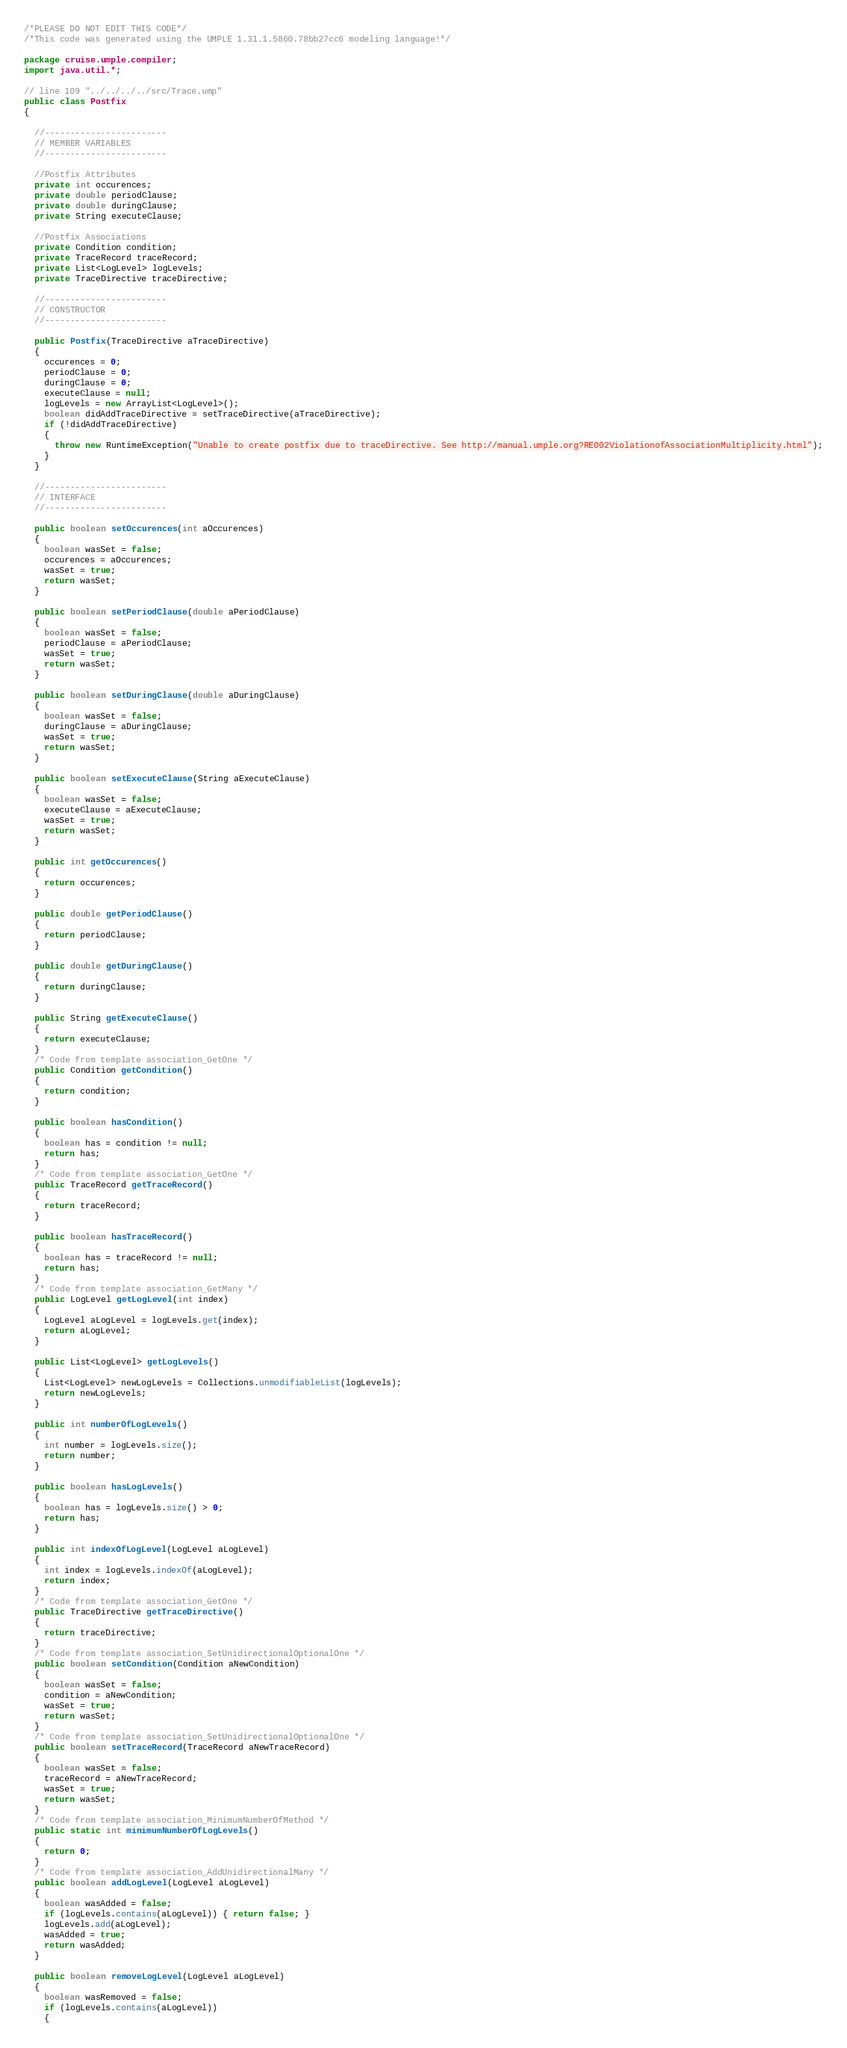Convert code to text. <code><loc_0><loc_0><loc_500><loc_500><_Java_>/*PLEASE DO NOT EDIT THIS CODE*/
/*This code was generated using the UMPLE 1.31.1.5860.78bb27cc6 modeling language!*/

package cruise.umple.compiler;
import java.util.*;

// line 109 "../../../../src/Trace.ump"
public class Postfix
{

  //------------------------
  // MEMBER VARIABLES
  //------------------------

  //Postfix Attributes
  private int occurences;
  private double periodClause;
  private double duringClause;
  private String executeClause;

  //Postfix Associations
  private Condition condition;
  private TraceRecord traceRecord;
  private List<LogLevel> logLevels;
  private TraceDirective traceDirective;

  //------------------------
  // CONSTRUCTOR
  //------------------------

  public Postfix(TraceDirective aTraceDirective)
  {
    occurences = 0;
    periodClause = 0;
    duringClause = 0;
    executeClause = null;
    logLevels = new ArrayList<LogLevel>();
    boolean didAddTraceDirective = setTraceDirective(aTraceDirective);
    if (!didAddTraceDirective)
    {
      throw new RuntimeException("Unable to create postfix due to traceDirective. See http://manual.umple.org?RE002ViolationofAssociationMultiplicity.html");
    }
  }

  //------------------------
  // INTERFACE
  //------------------------

  public boolean setOccurences(int aOccurences)
  {
    boolean wasSet = false;
    occurences = aOccurences;
    wasSet = true;
    return wasSet;
  }

  public boolean setPeriodClause(double aPeriodClause)
  {
    boolean wasSet = false;
    periodClause = aPeriodClause;
    wasSet = true;
    return wasSet;
  }

  public boolean setDuringClause(double aDuringClause)
  {
    boolean wasSet = false;
    duringClause = aDuringClause;
    wasSet = true;
    return wasSet;
  }

  public boolean setExecuteClause(String aExecuteClause)
  {
    boolean wasSet = false;
    executeClause = aExecuteClause;
    wasSet = true;
    return wasSet;
  }

  public int getOccurences()
  {
    return occurences;
  }

  public double getPeriodClause()
  {
    return periodClause;
  }

  public double getDuringClause()
  {
    return duringClause;
  }

  public String getExecuteClause()
  {
    return executeClause;
  }
  /* Code from template association_GetOne */
  public Condition getCondition()
  {
    return condition;
  }

  public boolean hasCondition()
  {
    boolean has = condition != null;
    return has;
  }
  /* Code from template association_GetOne */
  public TraceRecord getTraceRecord()
  {
    return traceRecord;
  }

  public boolean hasTraceRecord()
  {
    boolean has = traceRecord != null;
    return has;
  }
  /* Code from template association_GetMany */
  public LogLevel getLogLevel(int index)
  {
    LogLevel aLogLevel = logLevels.get(index);
    return aLogLevel;
  }

  public List<LogLevel> getLogLevels()
  {
    List<LogLevel> newLogLevels = Collections.unmodifiableList(logLevels);
    return newLogLevels;
  }

  public int numberOfLogLevels()
  {
    int number = logLevels.size();
    return number;
  }

  public boolean hasLogLevels()
  {
    boolean has = logLevels.size() > 0;
    return has;
  }

  public int indexOfLogLevel(LogLevel aLogLevel)
  {
    int index = logLevels.indexOf(aLogLevel);
    return index;
  }
  /* Code from template association_GetOne */
  public TraceDirective getTraceDirective()
  {
    return traceDirective;
  }
  /* Code from template association_SetUnidirectionalOptionalOne */
  public boolean setCondition(Condition aNewCondition)
  {
    boolean wasSet = false;
    condition = aNewCondition;
    wasSet = true;
    return wasSet;
  }
  /* Code from template association_SetUnidirectionalOptionalOne */
  public boolean setTraceRecord(TraceRecord aNewTraceRecord)
  {
    boolean wasSet = false;
    traceRecord = aNewTraceRecord;
    wasSet = true;
    return wasSet;
  }
  /* Code from template association_MinimumNumberOfMethod */
  public static int minimumNumberOfLogLevels()
  {
    return 0;
  }
  /* Code from template association_AddUnidirectionalMany */
  public boolean addLogLevel(LogLevel aLogLevel)
  {
    boolean wasAdded = false;
    if (logLevels.contains(aLogLevel)) { return false; }
    logLevels.add(aLogLevel);
    wasAdded = true;
    return wasAdded;
  }

  public boolean removeLogLevel(LogLevel aLogLevel)
  {
    boolean wasRemoved = false;
    if (logLevels.contains(aLogLevel))
    {</code> 